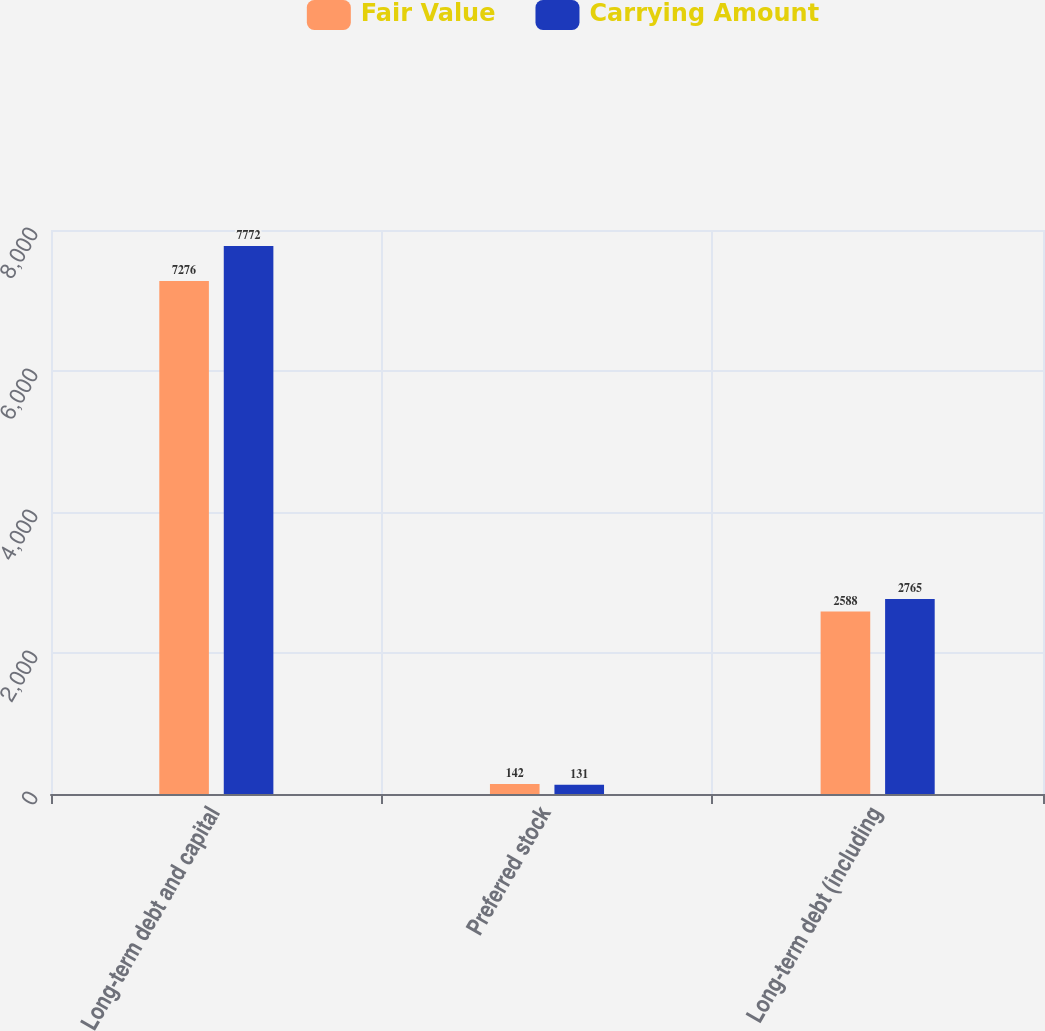Convert chart to OTSL. <chart><loc_0><loc_0><loc_500><loc_500><stacked_bar_chart><ecel><fcel>Long-term debt and capital<fcel>Preferred stock<fcel>Long-term debt (including<nl><fcel>Fair Value<fcel>7276<fcel>142<fcel>2588<nl><fcel>Carrying Amount<fcel>7772<fcel>131<fcel>2765<nl></chart> 